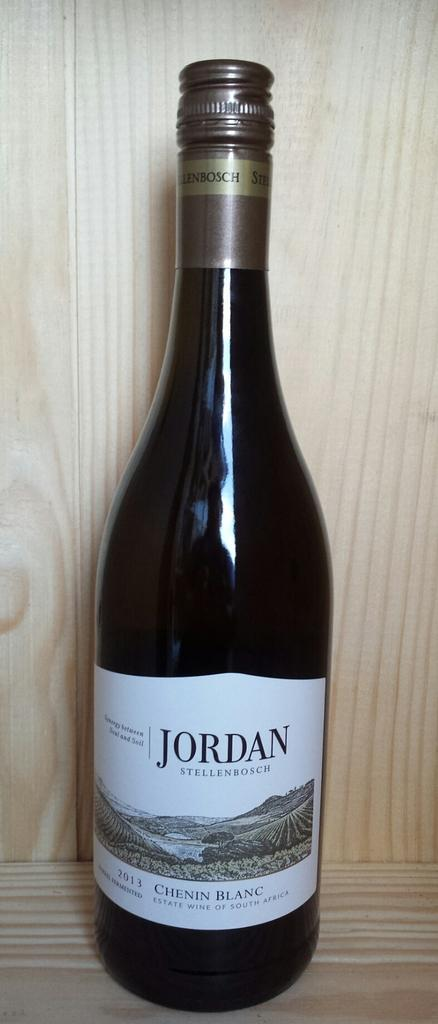<image>
Render a clear and concise summary of the photo. A bottle of Jordan chenin blanc has a mountain landscape on the label. 